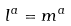Convert formula to latex. <formula><loc_0><loc_0><loc_500><loc_500>l ^ { a } = m ^ { a }</formula> 